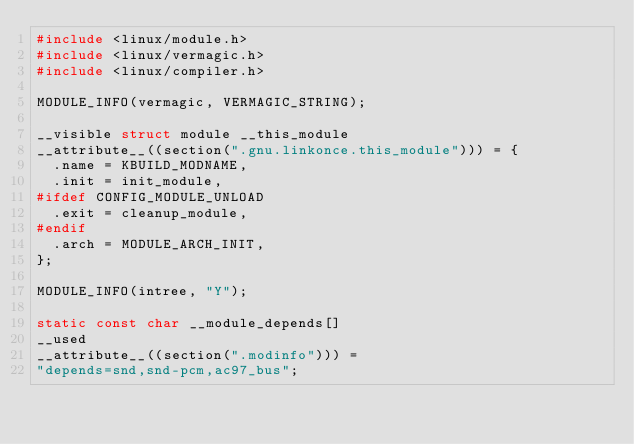<code> <loc_0><loc_0><loc_500><loc_500><_C_>#include <linux/module.h>
#include <linux/vermagic.h>
#include <linux/compiler.h>

MODULE_INFO(vermagic, VERMAGIC_STRING);

__visible struct module __this_module
__attribute__((section(".gnu.linkonce.this_module"))) = {
	.name = KBUILD_MODNAME,
	.init = init_module,
#ifdef CONFIG_MODULE_UNLOAD
	.exit = cleanup_module,
#endif
	.arch = MODULE_ARCH_INIT,
};

MODULE_INFO(intree, "Y");

static const char __module_depends[]
__used
__attribute__((section(".modinfo"))) =
"depends=snd,snd-pcm,ac97_bus";

</code> 